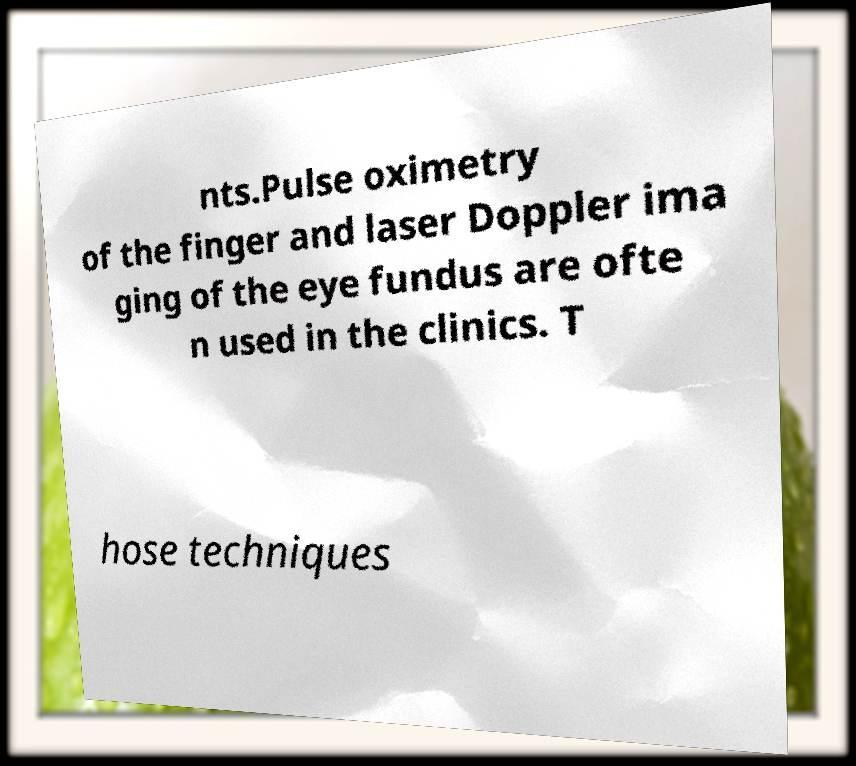Can you accurately transcribe the text from the provided image for me? nts.Pulse oximetry of the finger and laser Doppler ima ging of the eye fundus are ofte n used in the clinics. T hose techniques 